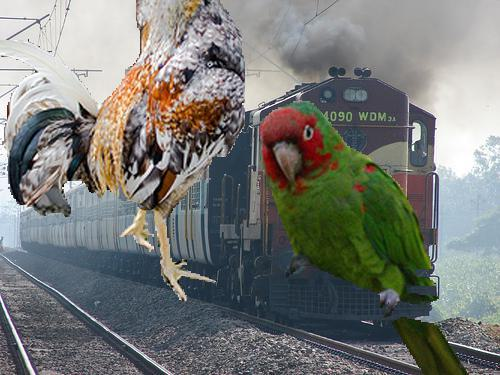What could be the symbolic significance of using a parrot and a chicken in this artwork? The inclusion of a parrot, known for its vivid colors and ability to mimic sounds, alongside a commonly domesticated and less colorful chicken, might symbolize a contrast between the exotic and the mundane. It can represent a dichotomy present in daily life or illustrate the diversity of nature encroaching on human spaces. 